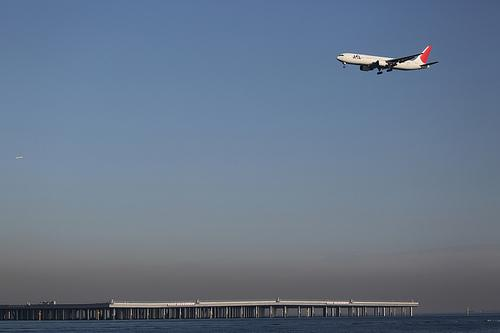Describe an advertisement for this plane using this image. Soar above the clouds and embrace the tranquility of the open skies with our state-of-the-art plane. Enjoy the breathtaking views and experience the freedom of flight, while leaving the world below. In a poetic manner, describe the colors and the atmosphere of the image. A canvas painted with soothing blue skies embraced by fluffy white clouds, where a graceful plane soars above a serene and dreamy ocean. List all the elements composed in the image. Plane, blue sky, clear blue ocean, pier, red tail fin, logo, calm blue water. Please state the general theme of the image by describing the scene. The scene features a plane flying above a calm blue ocean, with a clear blue sky in the background, creating a serene and tranquil atmosphere. What could be a question for a multi-choice VQA task in this image? What color is the tail fin of the plane? a) Blue b) Red c) Green d) Yellow What is the relation between the plane and the ocean in the scene? The plane is flying above the calm blue water of the ocean, creating a peaceful and harmonious scene. 